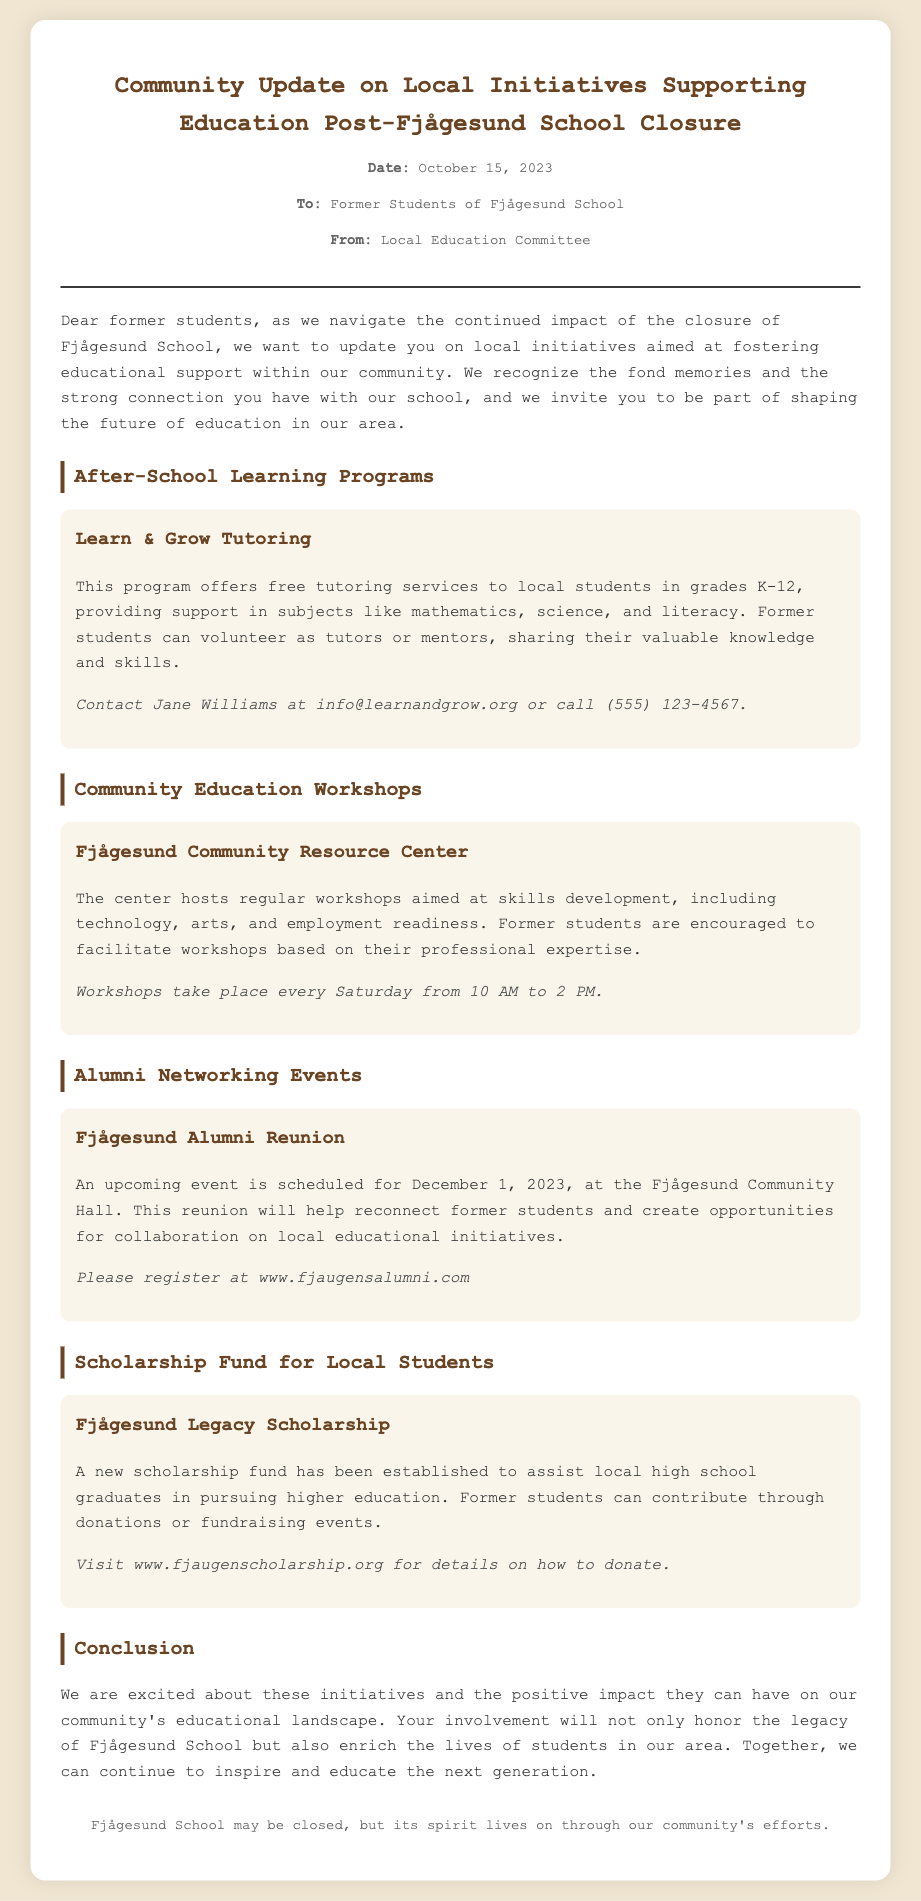What is the date of the community update? The date is mentioned in the memo's header, providing a specific reference for the update.
Answer: October 15, 2023 Who can be contacted for the Learn & Grow Tutoring program? The contact details for this program are provided within the section describing it, specifying who to reach out to for more information.
Answer: Jane Williams What day of the week do the community education workshops occur? The schedule for workshops is clearly outlined in the document, indicating the regularity and timing of these sessions.
Answer: Saturday What is the name of the scholarship fund mentioned? The document highlights a specific scholarship initiative that is intended to support local high school graduates, naming it directly.
Answer: Fjågesund Legacy Scholarship When is the Fjågesund Alumni Reunion scheduled? The date for this notable event is recorded within the section dedicated to alumni networking, indicating when former students can reconnect.
Answer: December 1, 2023 What type of contribution can former students make to the scholarship fund? The section about the scholarship fund indicates ways in which former students can participate in supporting local education financially.
Answer: Donations What subject areas does the Learn & Grow Tutoring program cover? The description of the tutoring program specifies the academic subjects offered, providing a clear overview of its focus areas.
Answer: Mathematics, science, literacy How often do workshops at the Fjågesund Community Resource Center occur? The document provides a schedule indicating how frequently these workshops are held, allowing for understanding of the program's structure.
Answer: Weekly What is the website for registering for the Fjågesund Alumni Reunion? The registration details for the reunion are given in the memo, specifically naming the online resource for former students.
Answer: www.fjaugensalumni.com 